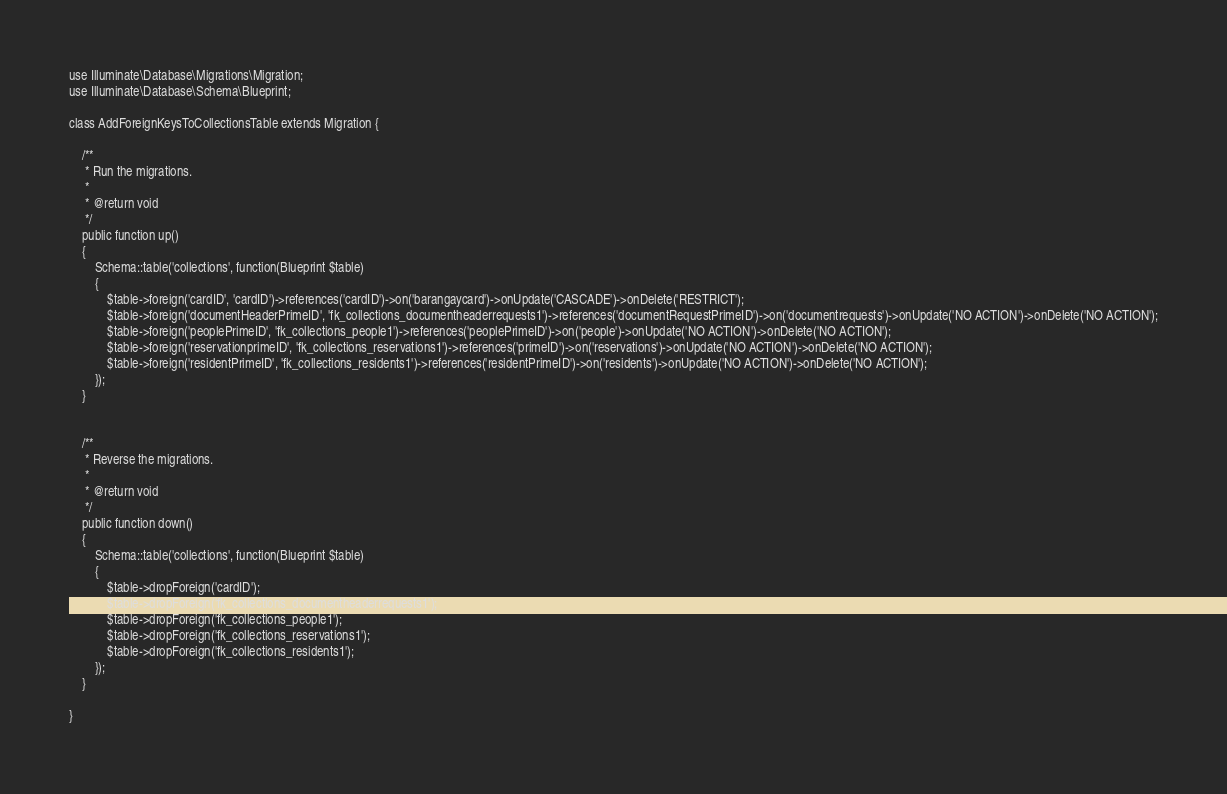<code> <loc_0><loc_0><loc_500><loc_500><_PHP_>use Illuminate\Database\Migrations\Migration;
use Illuminate\Database\Schema\Blueprint;

class AddForeignKeysToCollectionsTable extends Migration {

	/**
	 * Run the migrations.
	 *
	 * @return void
	 */
	public function up()
	{
		Schema::table('collections', function(Blueprint $table)
		{
			$table->foreign('cardID', 'cardID')->references('cardID')->on('barangaycard')->onUpdate('CASCADE')->onDelete('RESTRICT');
			$table->foreign('documentHeaderPrimeID', 'fk_collections_documentheaderrequests1')->references('documentRequestPrimeID')->on('documentrequests')->onUpdate('NO ACTION')->onDelete('NO ACTION');
			$table->foreign('peoplePrimeID', 'fk_collections_people1')->references('peoplePrimeID')->on('people')->onUpdate('NO ACTION')->onDelete('NO ACTION');
			$table->foreign('reservationprimeID', 'fk_collections_reservations1')->references('primeID')->on('reservations')->onUpdate('NO ACTION')->onDelete('NO ACTION');
			$table->foreign('residentPrimeID', 'fk_collections_residents1')->references('residentPrimeID')->on('residents')->onUpdate('NO ACTION')->onDelete('NO ACTION');
		});
	}


	/**
	 * Reverse the migrations.
	 *
	 * @return void
	 */
	public function down()
	{
		Schema::table('collections', function(Blueprint $table)
		{
			$table->dropForeign('cardID');
			$table->dropForeign('fk_collections_documentheaderrequests1');
			$table->dropForeign('fk_collections_people1');
			$table->dropForeign('fk_collections_reservations1');
			$table->dropForeign('fk_collections_residents1');
		});
	}

}
</code> 